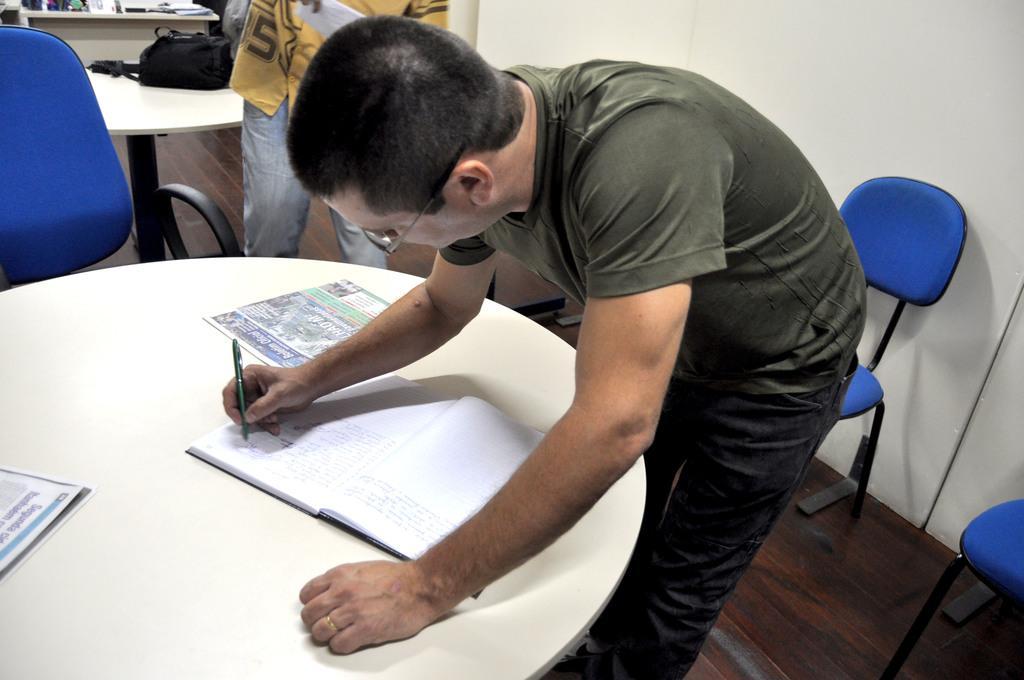How would you summarize this image in a sentence or two? Here we can see a man who is writing on the book. He has spectacles. This is table. On the table there are papers and book. This is floor and there are chairs. Here we can see a man and this is wall. There is a bag on the table. 